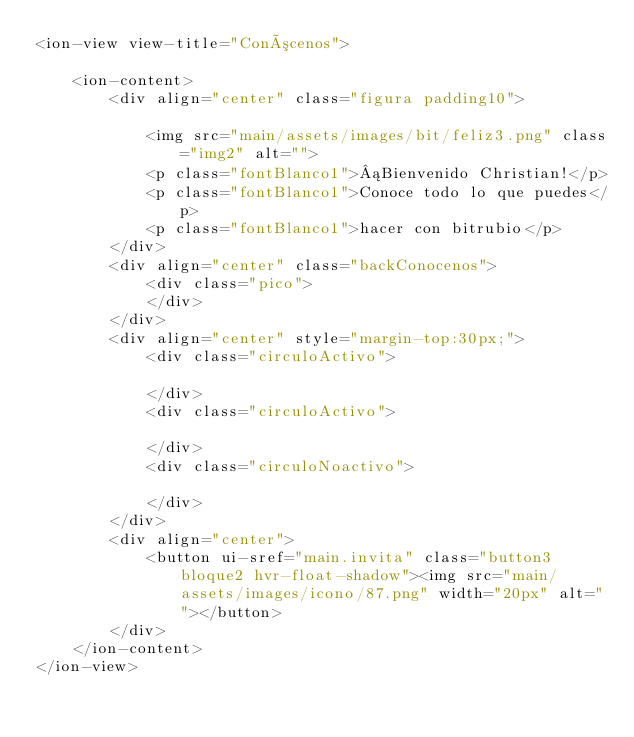<code> <loc_0><loc_0><loc_500><loc_500><_HTML_><ion-view view-title="Conócenos">

    <ion-content>
        <div align="center" class="figura padding10">

            <img src="main/assets/images/bit/feliz3.png" class="img2" alt="">
            <p class="fontBlanco1">¡Bienvenido Christian!</p>
            <p class="fontBlanco1">Conoce todo lo que puedes</p>
            <p class="fontBlanco1">hacer con bitrubio</p>
        </div>
        <div align="center" class="backConocenos">
            <div class="pico">
            </div>
        </div>
        <div align="center" style="margin-top:30px;">
            <div class="circuloActivo">

            </div>
            <div class="circuloActivo">

            </div>
            <div class="circuloNoactivo">

            </div>
        </div>
        <div align="center">
            <button ui-sref="main.invita" class="button3 bloque2 hvr-float-shadow"><img src="main/assets/images/icono/87.png" width="20px" alt=""></button>
        </div>
    </ion-content>
</ion-view></code> 